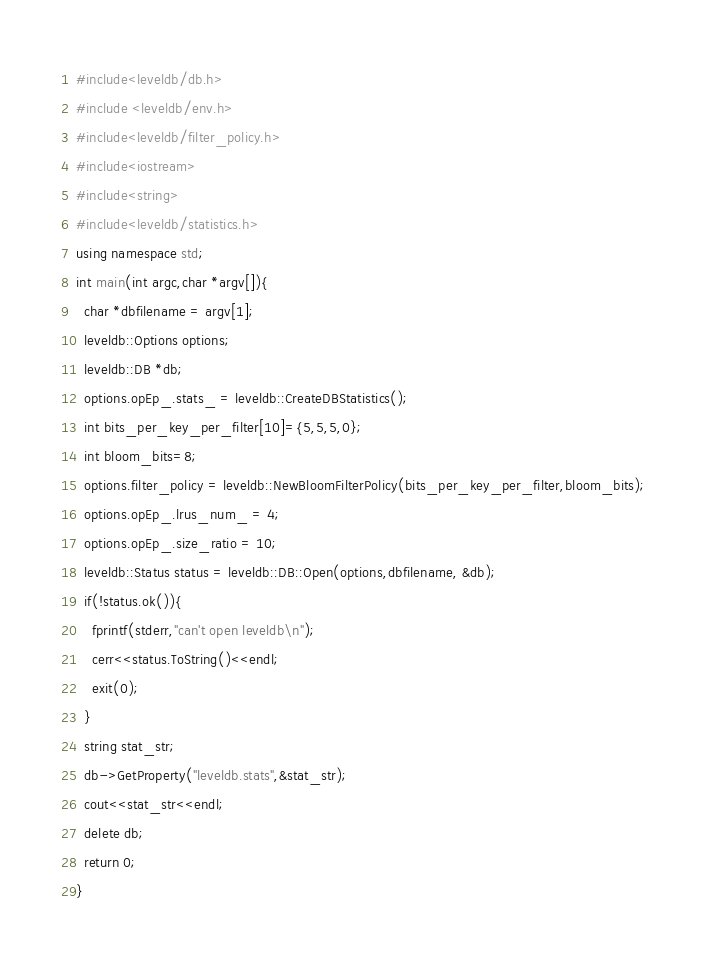<code> <loc_0><loc_0><loc_500><loc_500><_C++_>#include<leveldb/db.h>
#include <leveldb/env.h>
#include<leveldb/filter_policy.h>
#include<iostream>
#include<string>
#include<leveldb/statistics.h>
using namespace std;
int main(int argc,char *argv[]){
  char *dbfilename = argv[1];
  leveldb::Options options;
  leveldb::DB *db;
  options.opEp_.stats_ = leveldb::CreateDBStatistics();
  int bits_per_key_per_filter[10]={5,5,5,0};
  int bloom_bits=8;
  options.filter_policy = leveldb::NewBloomFilterPolicy(bits_per_key_per_filter,bloom_bits);
  options.opEp_.lrus_num_ = 4;
  options.opEp_.size_ratio = 10;
  leveldb::Status status = leveldb::DB::Open(options,dbfilename, &db);
  if(!status.ok()){
    fprintf(stderr,"can't open leveldb\n");
    cerr<<status.ToString()<<endl;
    exit(0);
  }
  string stat_str;
  db->GetProperty("leveldb.stats",&stat_str);
  cout<<stat_str<<endl;
  delete db;
  return 0;
}
</code> 